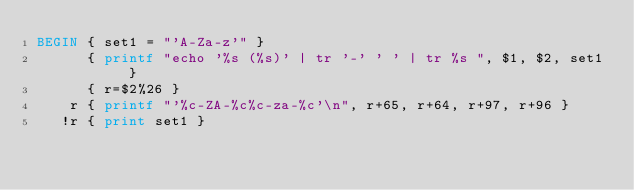<code> <loc_0><loc_0><loc_500><loc_500><_Awk_>BEGIN { set1 = "'A-Za-z'" }
      { printf "echo '%s (%s)' | tr '-' ' ' | tr %s ", $1, $2, set1 }
      { r=$2%26 }
    r { printf "'%c-ZA-%c%c-za-%c'\n", r+65, r+64, r+97, r+96 }
   !r { print set1 }
</code> 